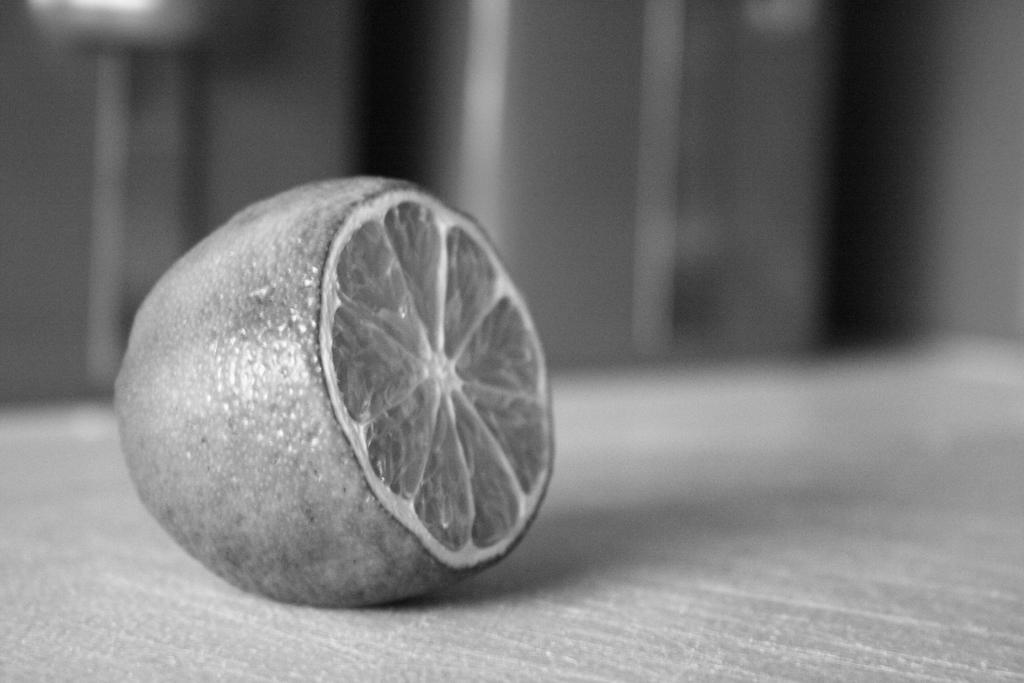What fruit is present in the image? There is a lemon in the image. Where is the lemon placed? The lemon is on a surface. Can you describe the background of the image? The background of the image is blurred. How many pies are being held by the lemon in the image? There are no pies present in the image, and the lemon is not holding anything. 